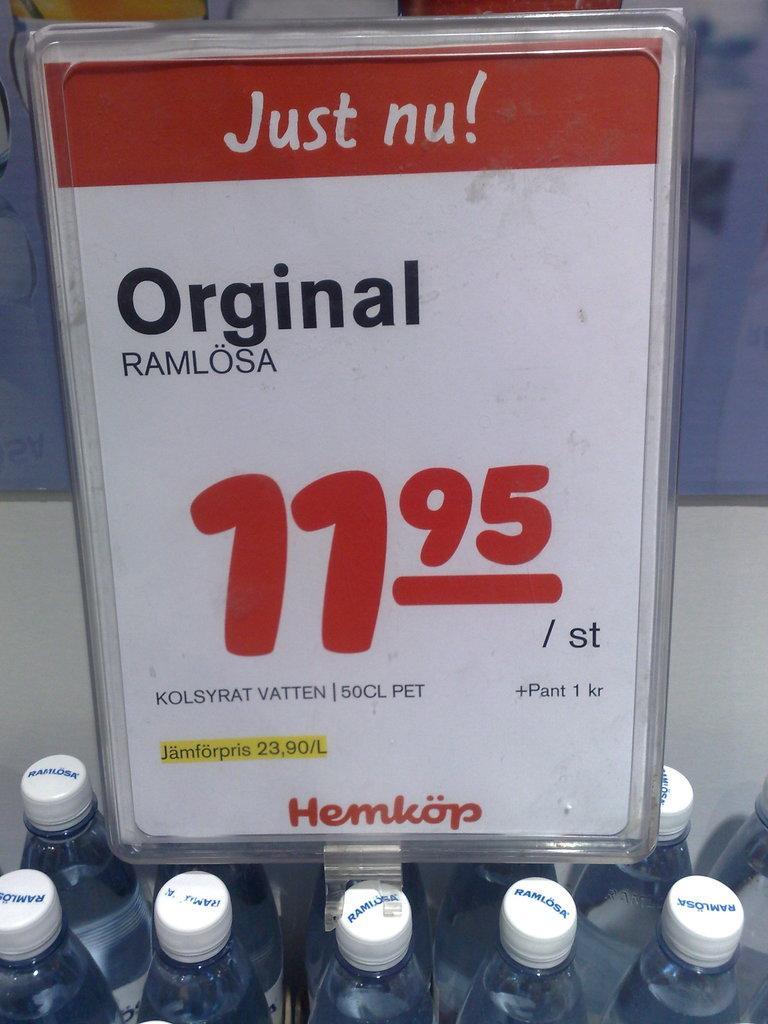Please provide a concise description of this image. Here we can see a group of bottles present and above that we can see price card present 